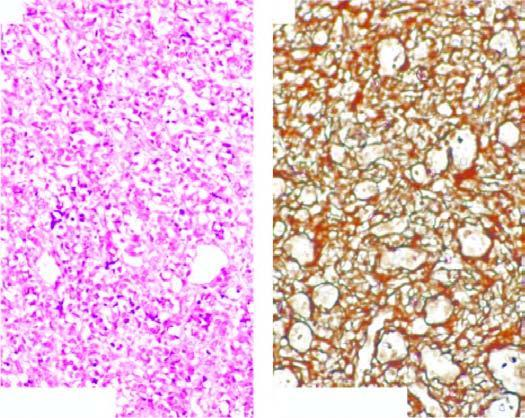what shows condensation of reticulin around the vessel wall but not between the proliferating cells?
Answer the question using a single word or phrase. Reticulin stain 